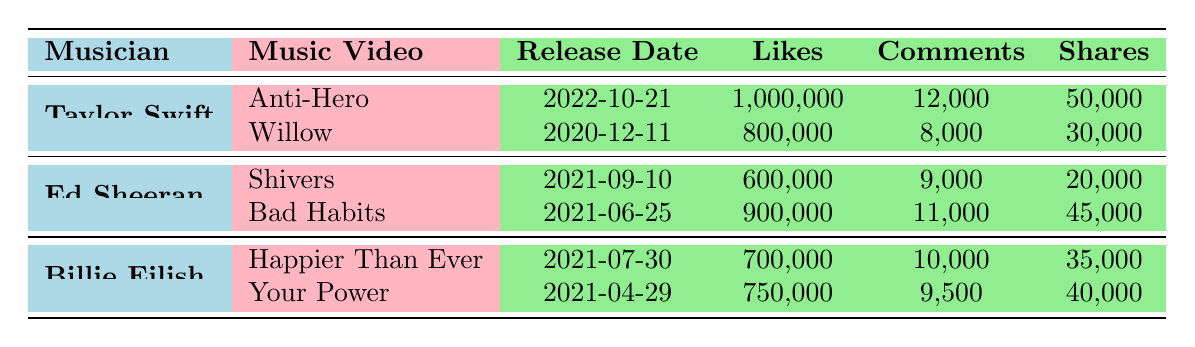What is the total number of likes for all music videos by Taylor Swift? To find the total likes for Taylor Swift, we sum the likes of her two music videos: Anti-Hero (1,000,000) and Willow (800,000). Therefore, 1,000,000 + 800,000 = 1,800,000.
Answer: 1,800,000 Which music video has the highest number of comments? By comparing the comments for each music video, we see that Anti-Hero has 12,000 comments, Willow has 8,000, Shivers has 9,000, Bad Habits has 11,000, Happier Than Ever has 10,000, and Your Power has 9,500. The highest number is 12,000 for Anti-Hero.
Answer: Anti-Hero Did Ed Sheeran's video "Shivers" receive more likes than Billie Eilish's video "Your Power"? Ed Sheeran's "Shivers" received 600,000 likes, while Billie Eilish's "Your Power" received 750,000 likes. Since 600,000 is less than 750,000, the statement is false.
Answer: No What is the average number of shares across all music videos? We first sum all the shares: Anti-Hero (50,000), Willow (30,000), Shivers (20,000), Bad Habits (45,000), Happier Than Ever (35,000), and Your Power (40,000). The total is 50,000 + 30,000 + 20,000 + 45,000 + 35,000 + 40,000 = 220,000. There are 6 music videos, so the average is 220,000 / 6 = 36,666.67.
Answer: 36,666.67 Which musician has the most total shares from their music videos? To determine this, we sum the shares for each musician: Taylor Swift has 50,000 + 30,000 = 80,000; Ed Sheeran has 20,000 + 45,000 = 65,000; Billie Eilish has 35,000 + 40,000 = 75,000. Comparatively, Taylor Swift has the most at 80,000 shares.
Answer: Taylor Swift 